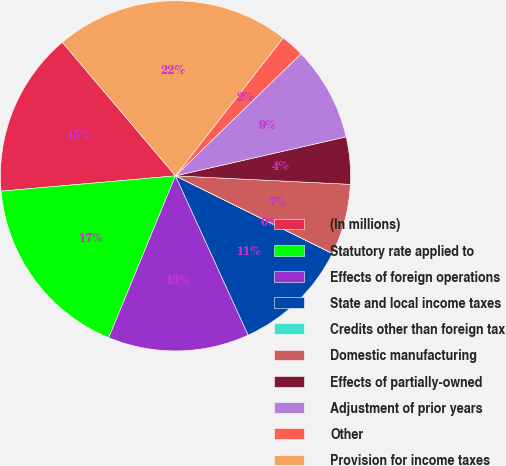<chart> <loc_0><loc_0><loc_500><loc_500><pie_chart><fcel>(In millions)<fcel>Statutory rate applied to<fcel>Effects of foreign operations<fcel>State and local income taxes<fcel>Credits other than foreign tax<fcel>Domestic manufacturing<fcel>Effects of partially-owned<fcel>Adjustment of prior years<fcel>Other<fcel>Provision for income taxes<nl><fcel>15.21%<fcel>17.38%<fcel>13.04%<fcel>10.87%<fcel>0.01%<fcel>6.53%<fcel>4.35%<fcel>8.7%<fcel>2.18%<fcel>21.73%<nl></chart> 